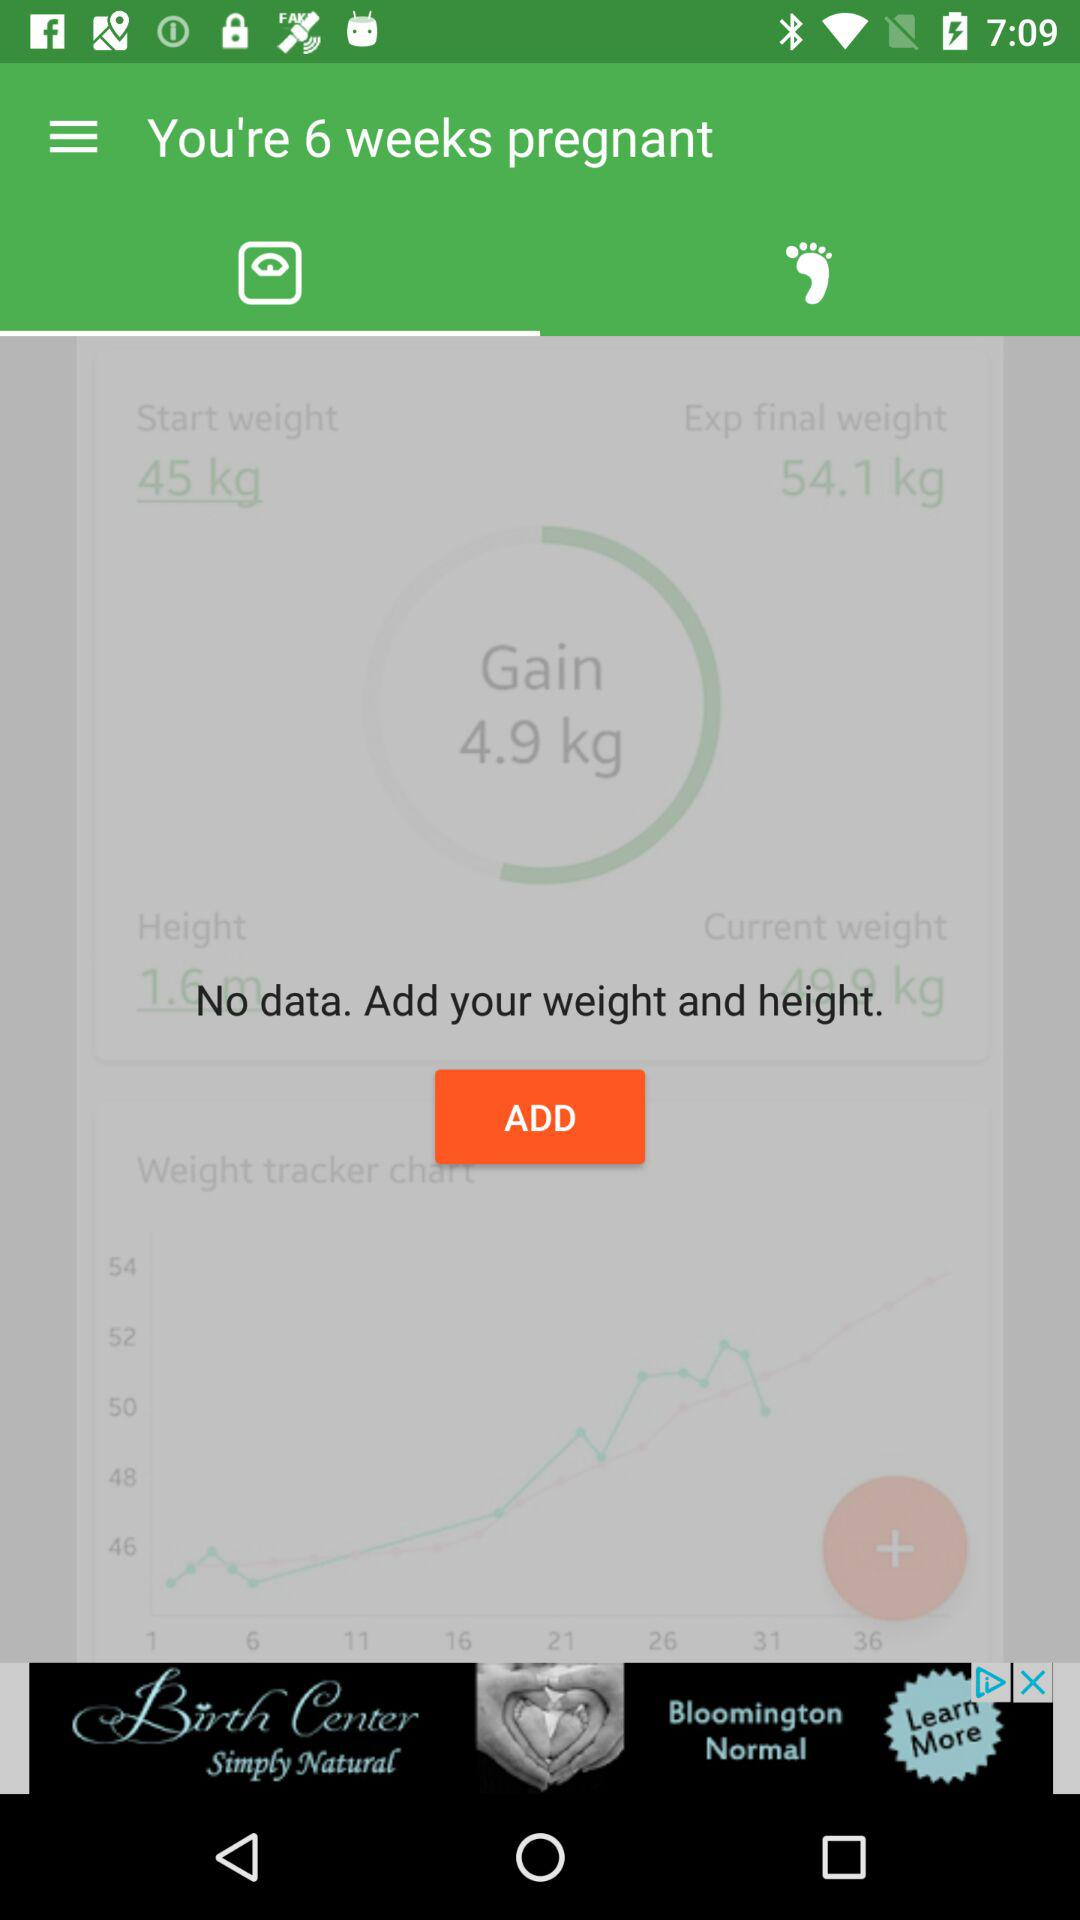How much weight has the user gained so far?
Answer the question using a single word or phrase. 4.9 kg 